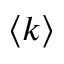Convert formula to latex. <formula><loc_0><loc_0><loc_500><loc_500>\langle k \rangle</formula> 